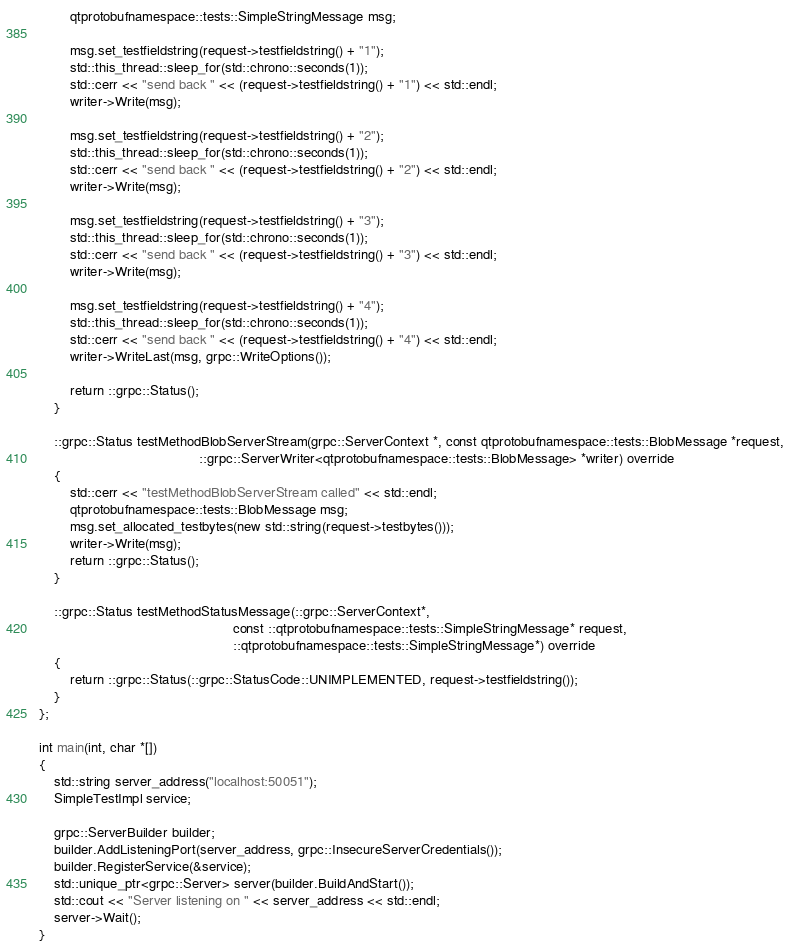Convert code to text. <code><loc_0><loc_0><loc_500><loc_500><_C++_>        qtprotobufnamespace::tests::SimpleStringMessage msg;

        msg.set_testfieldstring(request->testfieldstring() + "1");
        std::this_thread::sleep_for(std::chrono::seconds(1));
        std::cerr << "send back " << (request->testfieldstring() + "1") << std::endl;
        writer->Write(msg);

        msg.set_testfieldstring(request->testfieldstring() + "2");
        std::this_thread::sleep_for(std::chrono::seconds(1));
        std::cerr << "send back " << (request->testfieldstring() + "2") << std::endl;
        writer->Write(msg);

        msg.set_testfieldstring(request->testfieldstring() + "3");
        std::this_thread::sleep_for(std::chrono::seconds(1));
        std::cerr << "send back " << (request->testfieldstring() + "3") << std::endl;
        writer->Write(msg);

        msg.set_testfieldstring(request->testfieldstring() + "4");
        std::this_thread::sleep_for(std::chrono::seconds(1));
        std::cerr << "send back " << (request->testfieldstring() + "4") << std::endl;
        writer->WriteLast(msg, grpc::WriteOptions());

        return ::grpc::Status();
    }

    ::grpc::Status testMethodBlobServerStream(grpc::ServerContext *, const qtprotobufnamespace::tests::BlobMessage *request,
                                          ::grpc::ServerWriter<qtprotobufnamespace::tests::BlobMessage> *writer) override
    {
        std::cerr << "testMethodBlobServerStream called" << std::endl;
        qtprotobufnamespace::tests::BlobMessage msg;
        msg.set_allocated_testbytes(new std::string(request->testbytes()));
        writer->Write(msg);
        return ::grpc::Status();
    }

    ::grpc::Status testMethodStatusMessage(::grpc::ServerContext*,
                                                   const ::qtprotobufnamespace::tests::SimpleStringMessage* request,
                                                   ::qtprotobufnamespace::tests::SimpleStringMessage*) override
    {
        return ::grpc::Status(::grpc::StatusCode::UNIMPLEMENTED, request->testfieldstring());
    }
};

int main(int, char *[])
{
    std::string server_address("localhost:50051");
    SimpleTestImpl service;

    grpc::ServerBuilder builder;
    builder.AddListeningPort(server_address, grpc::InsecureServerCredentials());
    builder.RegisterService(&service);
    std::unique_ptr<grpc::Server> server(builder.BuildAndStart());
    std::cout << "Server listening on " << server_address << std::endl;
    server->Wait();
}
</code> 